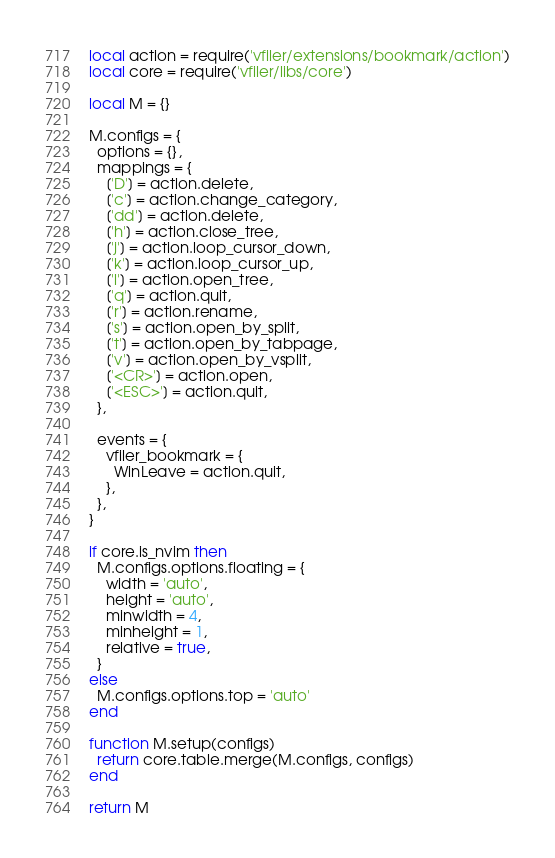<code> <loc_0><loc_0><loc_500><loc_500><_Lua_>local action = require('vfiler/extensions/bookmark/action')
local core = require('vfiler/libs/core')

local M = {}

M.configs = {
  options = {},
  mappings = {
    ['D'] = action.delete,
    ['c'] = action.change_category,
    ['dd'] = action.delete,
    ['h'] = action.close_tree,
    ['j'] = action.loop_cursor_down,
    ['k'] = action.loop_cursor_up,
    ['l'] = action.open_tree,
    ['q'] = action.quit,
    ['r'] = action.rename,
    ['s'] = action.open_by_split,
    ['t'] = action.open_by_tabpage,
    ['v'] = action.open_by_vsplit,
    ['<CR>'] = action.open,
    ['<ESC>'] = action.quit,
  },

  events = {
    vfiler_bookmark = {
      WinLeave = action.quit,
    },
  },
}

if core.is_nvim then
  M.configs.options.floating = {
    width = 'auto',
    height = 'auto',
    minwidth = 4,
    minheight = 1,
    relative = true,
  }
else
  M.configs.options.top = 'auto'
end

function M.setup(configs)
  return core.table.merge(M.configs, configs)
end

return M
</code> 